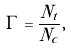Convert formula to latex. <formula><loc_0><loc_0><loc_500><loc_500>\Gamma = \frac { N _ { t } } { N _ { c } } ,</formula> 